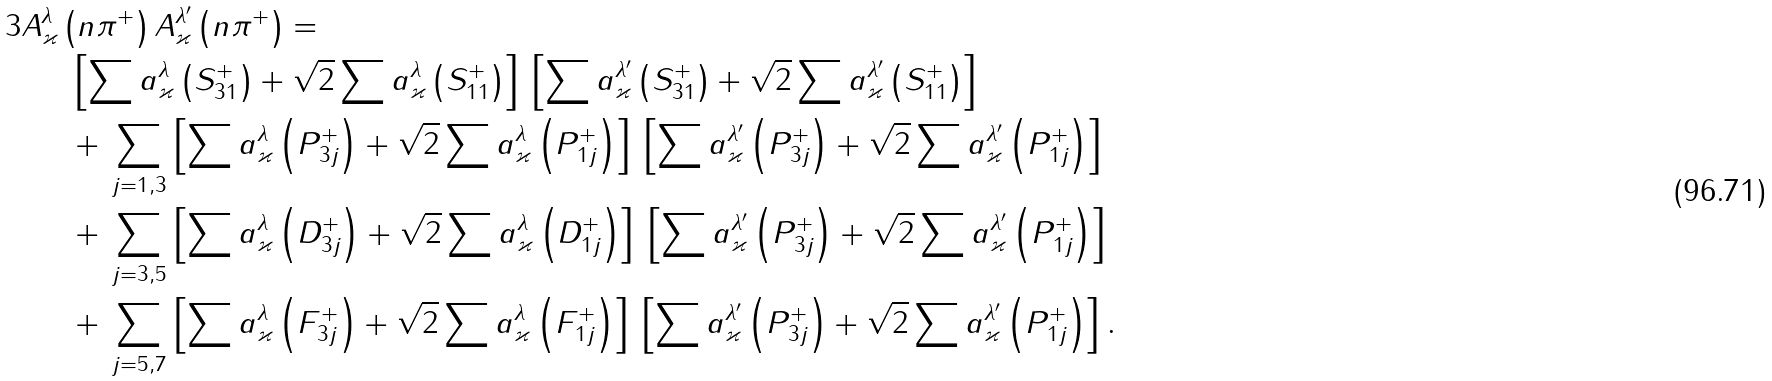<formula> <loc_0><loc_0><loc_500><loc_500>3 A _ { \varkappa } ^ { \lambda } & \left ( n \pi ^ { + } \right ) A _ { \varkappa } ^ { \lambda ^ { \prime } } \left ( n \pi ^ { + } \right ) = \\ & \ \left [ \sum a ^ { \lambda } _ { \varkappa } \left ( S ^ { + } _ { 3 1 } \right ) + \sqrt { 2 } \sum a ^ { \lambda } _ { \varkappa } \left ( S ^ { + } _ { 1 1 } \right ) \right ] \, \left [ \sum a ^ { \lambda ^ { \prime } } _ { \varkappa } \left ( S ^ { + } _ { 3 1 } \right ) + \sqrt { 2 } \sum a ^ { \lambda ^ { \prime } } _ { \varkappa } \left ( S ^ { + } _ { 1 1 } \right ) \right ] \\ & \ + \, \sum _ { j = 1 , 3 } \left [ \sum a ^ { \lambda } _ { \varkappa } \left ( P ^ { + } _ { 3 j } \right ) + \sqrt { 2 } \sum a ^ { \lambda } _ { \varkappa } \left ( P ^ { + } _ { 1 j } \right ) \right ] \, \left [ \sum a ^ { \lambda ^ { \prime } } _ { \varkappa } \left ( P ^ { + } _ { 3 j } \right ) + \sqrt { 2 } \sum a ^ { \lambda ^ { \prime } } _ { \varkappa } \left ( P ^ { + } _ { 1 j } \right ) \right ] \\ & \ + \, \sum _ { j = 3 , 5 } \left [ \sum a ^ { \lambda } _ { \varkappa } \left ( D ^ { + } _ { 3 j } \right ) + \sqrt { 2 } \sum a ^ { \lambda } _ { \varkappa } \left ( D ^ { + } _ { 1 j } \right ) \right ] \, \left [ \sum a ^ { \lambda ^ { \prime } } _ { \varkappa } \left ( P ^ { + } _ { 3 j } \right ) + \sqrt { 2 } \sum a ^ { \lambda ^ { \prime } } _ { \varkappa } \left ( P ^ { + } _ { 1 j } \right ) \right ] \\ & \ + \, \sum _ { j = 5 , 7 } \left [ \sum a ^ { \lambda } _ { \varkappa } \left ( F ^ { + } _ { 3 j } \right ) + \sqrt { 2 } \sum a ^ { \lambda } _ { \varkappa } \left ( F ^ { + } _ { 1 j } \right ) \right ] \, \left [ \sum a ^ { \lambda ^ { \prime } } _ { \varkappa } \left ( P ^ { + } _ { 3 j } \right ) + \sqrt { 2 } \sum a ^ { \lambda ^ { \prime } } _ { \varkappa } \left ( P ^ { + } _ { 1 j } \right ) \right ] .</formula> 